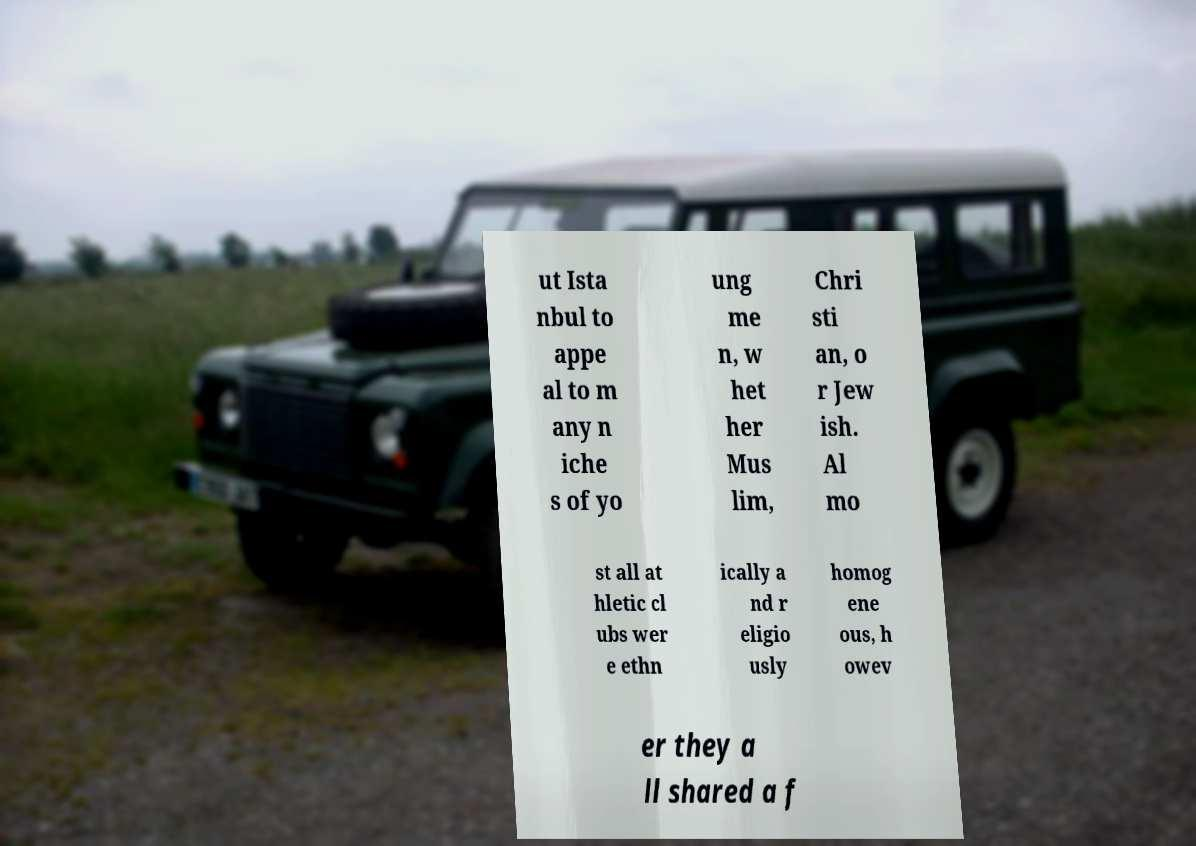Please identify and transcribe the text found in this image. ut Ista nbul to appe al to m any n iche s of yo ung me n, w het her Mus lim, Chri sti an, o r Jew ish. Al mo st all at hletic cl ubs wer e ethn ically a nd r eligio usly homog ene ous, h owev er they a ll shared a f 